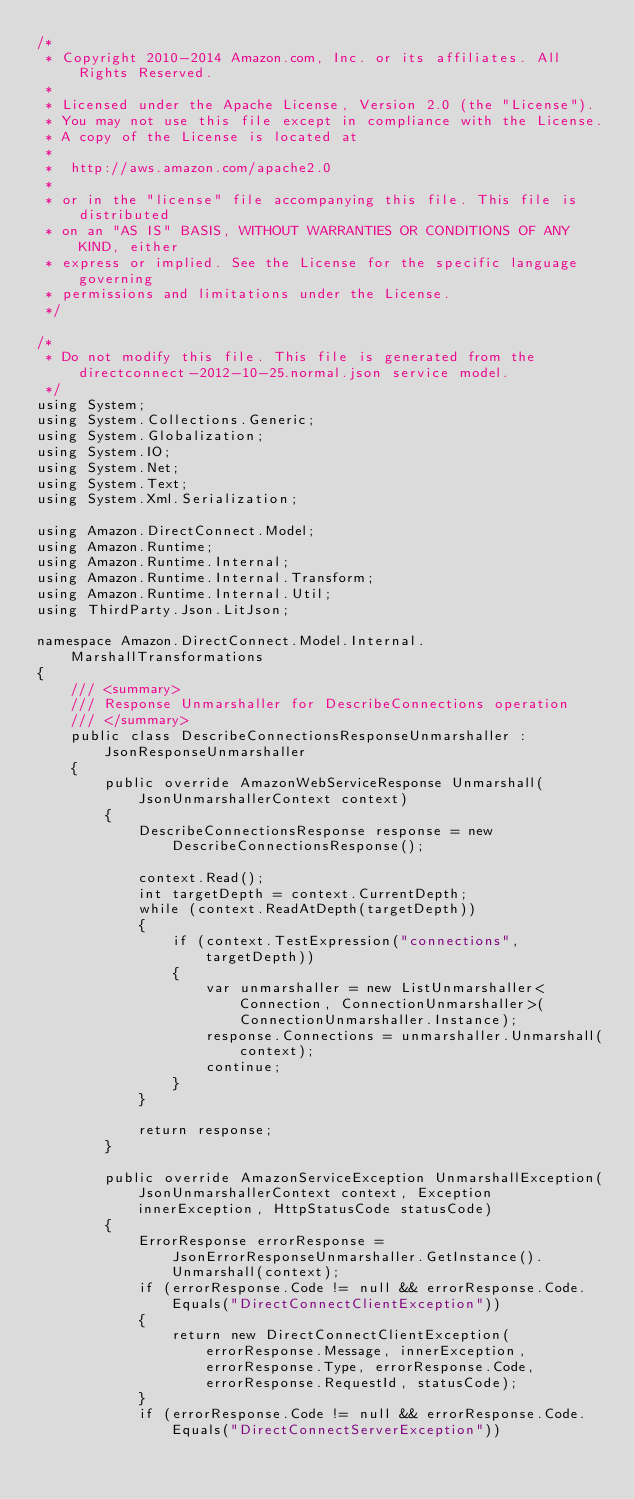Convert code to text. <code><loc_0><loc_0><loc_500><loc_500><_C#_>/*
 * Copyright 2010-2014 Amazon.com, Inc. or its affiliates. All Rights Reserved.
 * 
 * Licensed under the Apache License, Version 2.0 (the "License").
 * You may not use this file except in compliance with the License.
 * A copy of the License is located at
 * 
 *  http://aws.amazon.com/apache2.0
 * 
 * or in the "license" file accompanying this file. This file is distributed
 * on an "AS IS" BASIS, WITHOUT WARRANTIES OR CONDITIONS OF ANY KIND, either
 * express or implied. See the License for the specific language governing
 * permissions and limitations under the License.
 */

/*
 * Do not modify this file. This file is generated from the directconnect-2012-10-25.normal.json service model.
 */
using System;
using System.Collections.Generic;
using System.Globalization;
using System.IO;
using System.Net;
using System.Text;
using System.Xml.Serialization;

using Amazon.DirectConnect.Model;
using Amazon.Runtime;
using Amazon.Runtime.Internal;
using Amazon.Runtime.Internal.Transform;
using Amazon.Runtime.Internal.Util;
using ThirdParty.Json.LitJson;

namespace Amazon.DirectConnect.Model.Internal.MarshallTransformations
{
    /// <summary>
    /// Response Unmarshaller for DescribeConnections operation
    /// </summary>  
    public class DescribeConnectionsResponseUnmarshaller : JsonResponseUnmarshaller
    {
        public override AmazonWebServiceResponse Unmarshall(JsonUnmarshallerContext context)
        {
            DescribeConnectionsResponse response = new DescribeConnectionsResponse();

            context.Read();
            int targetDepth = context.CurrentDepth;
            while (context.ReadAtDepth(targetDepth))
            {
                if (context.TestExpression("connections", targetDepth))
                {
                    var unmarshaller = new ListUnmarshaller<Connection, ConnectionUnmarshaller>(ConnectionUnmarshaller.Instance);
                    response.Connections = unmarshaller.Unmarshall(context);
                    continue;
                }
            }

            return response;
        }

        public override AmazonServiceException UnmarshallException(JsonUnmarshallerContext context, Exception innerException, HttpStatusCode statusCode)
        {
            ErrorResponse errorResponse = JsonErrorResponseUnmarshaller.GetInstance().Unmarshall(context);
            if (errorResponse.Code != null && errorResponse.Code.Equals("DirectConnectClientException"))
            {
                return new DirectConnectClientException(errorResponse.Message, innerException, errorResponse.Type, errorResponse.Code, errorResponse.RequestId, statusCode);
            }
            if (errorResponse.Code != null && errorResponse.Code.Equals("DirectConnectServerException"))</code> 